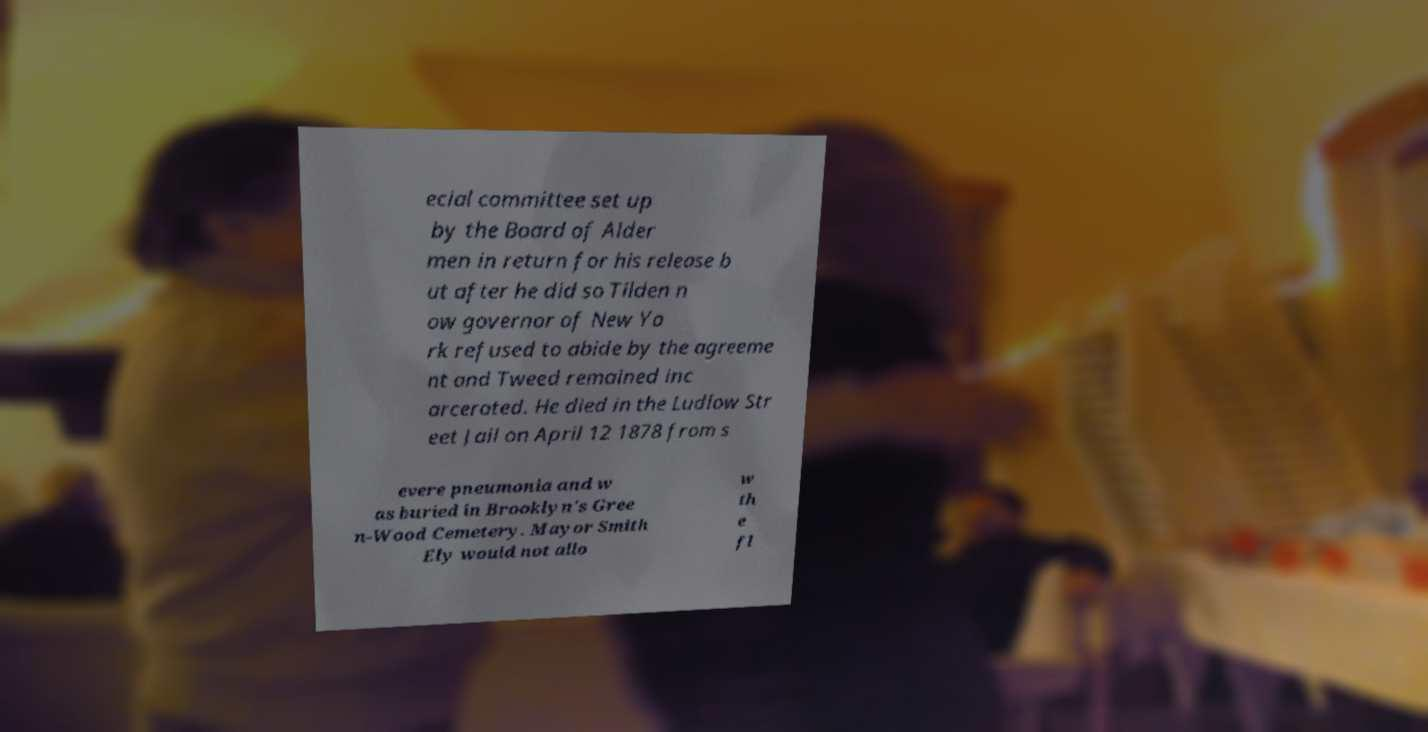Can you accurately transcribe the text from the provided image for me? ecial committee set up by the Board of Alder men in return for his release b ut after he did so Tilden n ow governor of New Yo rk refused to abide by the agreeme nt and Tweed remained inc arcerated. He died in the Ludlow Str eet Jail on April 12 1878 from s evere pneumonia and w as buried in Brooklyn's Gree n-Wood Cemetery. Mayor Smith Ely would not allo w th e fl 